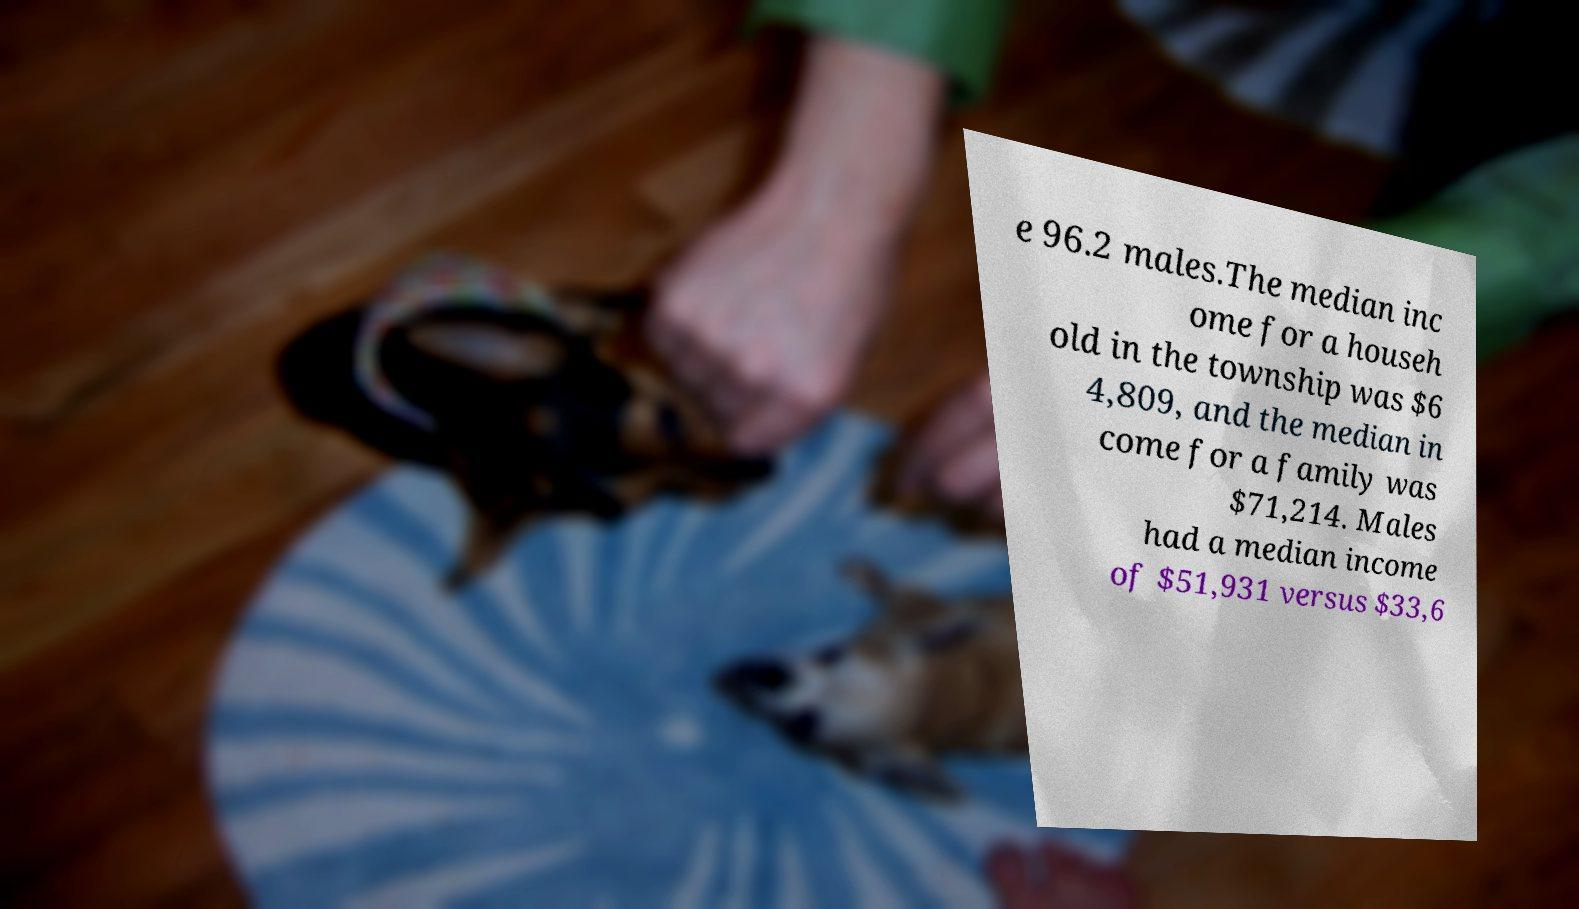What messages or text are displayed in this image? I need them in a readable, typed format. e 96.2 males.The median inc ome for a househ old in the township was $6 4,809, and the median in come for a family was $71,214. Males had a median income of $51,931 versus $33,6 